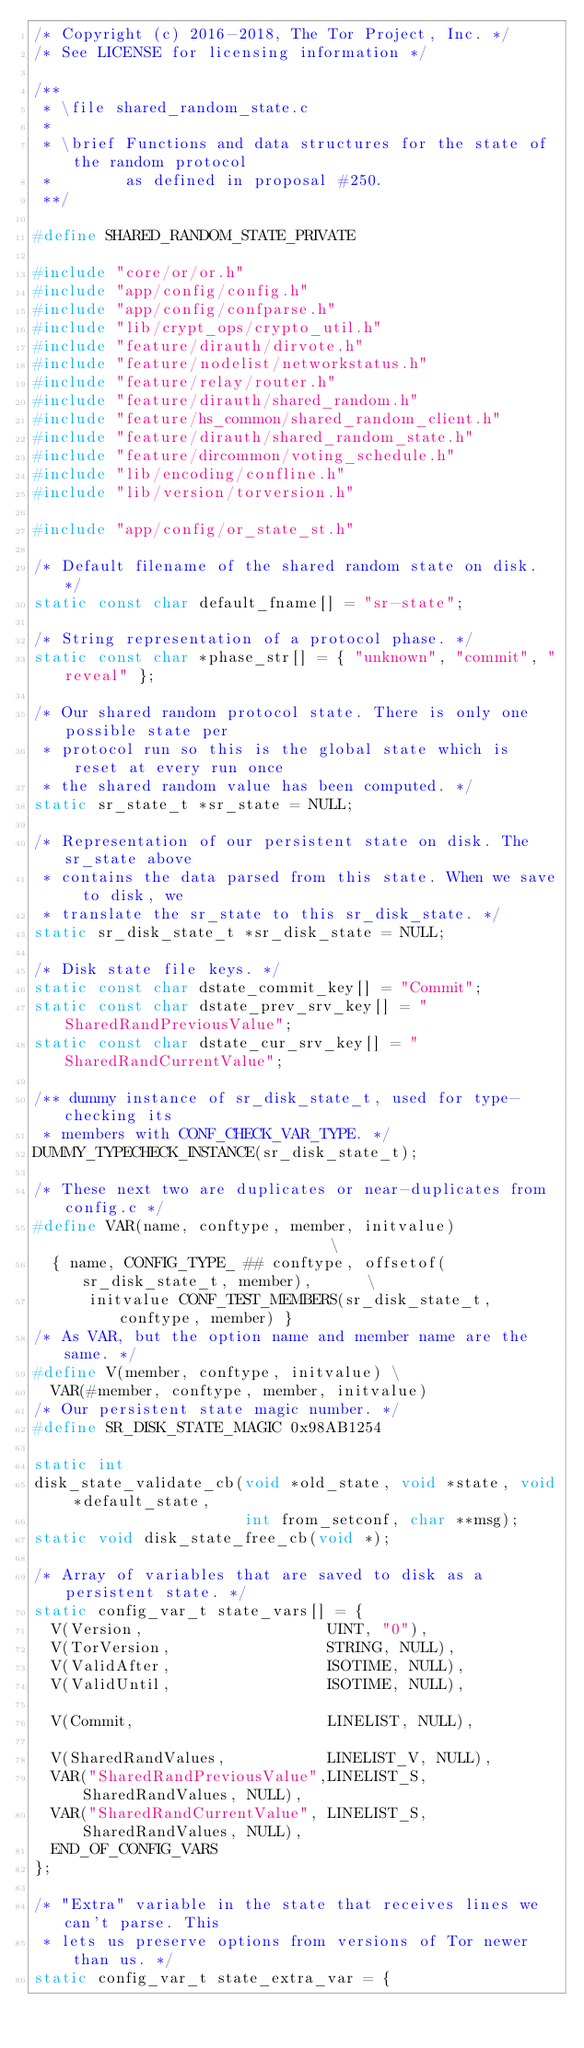Convert code to text. <code><loc_0><loc_0><loc_500><loc_500><_C_>/* Copyright (c) 2016-2018, The Tor Project, Inc. */
/* See LICENSE for licensing information */

/**
 * \file shared_random_state.c
 *
 * \brief Functions and data structures for the state of the random protocol
 *        as defined in proposal #250.
 **/

#define SHARED_RANDOM_STATE_PRIVATE

#include "core/or/or.h"
#include "app/config/config.h"
#include "app/config/confparse.h"
#include "lib/crypt_ops/crypto_util.h"
#include "feature/dirauth/dirvote.h"
#include "feature/nodelist/networkstatus.h"
#include "feature/relay/router.h"
#include "feature/dirauth/shared_random.h"
#include "feature/hs_common/shared_random_client.h"
#include "feature/dirauth/shared_random_state.h"
#include "feature/dircommon/voting_schedule.h"
#include "lib/encoding/confline.h"
#include "lib/version/torversion.h"

#include "app/config/or_state_st.h"

/* Default filename of the shared random state on disk. */
static const char default_fname[] = "sr-state";

/* String representation of a protocol phase. */
static const char *phase_str[] = { "unknown", "commit", "reveal" };

/* Our shared random protocol state. There is only one possible state per
 * protocol run so this is the global state which is reset at every run once
 * the shared random value has been computed. */
static sr_state_t *sr_state = NULL;

/* Representation of our persistent state on disk. The sr_state above
 * contains the data parsed from this state. When we save to disk, we
 * translate the sr_state to this sr_disk_state. */
static sr_disk_state_t *sr_disk_state = NULL;

/* Disk state file keys. */
static const char dstate_commit_key[] = "Commit";
static const char dstate_prev_srv_key[] = "SharedRandPreviousValue";
static const char dstate_cur_srv_key[] = "SharedRandCurrentValue";

/** dummy instance of sr_disk_state_t, used for type-checking its
 * members with CONF_CHECK_VAR_TYPE. */
DUMMY_TYPECHECK_INSTANCE(sr_disk_state_t);

/* These next two are duplicates or near-duplicates from config.c */
#define VAR(name, conftype, member, initvalue)                              \
  { name, CONFIG_TYPE_ ## conftype, offsetof(sr_disk_state_t, member),      \
      initvalue CONF_TEST_MEMBERS(sr_disk_state_t, conftype, member) }
/* As VAR, but the option name and member name are the same. */
#define V(member, conftype, initvalue) \
  VAR(#member, conftype, member, initvalue)
/* Our persistent state magic number. */
#define SR_DISK_STATE_MAGIC 0x98AB1254

static int
disk_state_validate_cb(void *old_state, void *state, void *default_state,
                       int from_setconf, char **msg);
static void disk_state_free_cb(void *);

/* Array of variables that are saved to disk as a persistent state. */
static config_var_t state_vars[] = {
  V(Version,                    UINT, "0"),
  V(TorVersion,                 STRING, NULL),
  V(ValidAfter,                 ISOTIME, NULL),
  V(ValidUntil,                 ISOTIME, NULL),

  V(Commit,                     LINELIST, NULL),

  V(SharedRandValues,           LINELIST_V, NULL),
  VAR("SharedRandPreviousValue",LINELIST_S, SharedRandValues, NULL),
  VAR("SharedRandCurrentValue", LINELIST_S, SharedRandValues, NULL),
  END_OF_CONFIG_VARS
};

/* "Extra" variable in the state that receives lines we can't parse. This
 * lets us preserve options from versions of Tor newer than us. */
static config_var_t state_extra_var = {</code> 